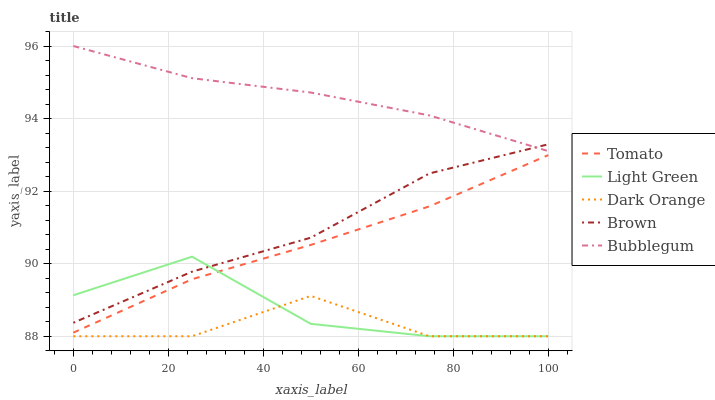Does Dark Orange have the minimum area under the curve?
Answer yes or no. Yes. Does Bubblegum have the maximum area under the curve?
Answer yes or no. Yes. Does Bubblegum have the minimum area under the curve?
Answer yes or no. No. Does Dark Orange have the maximum area under the curve?
Answer yes or no. No. Is Tomato the smoothest?
Answer yes or no. Yes. Is Light Green the roughest?
Answer yes or no. Yes. Is Dark Orange the smoothest?
Answer yes or no. No. Is Dark Orange the roughest?
Answer yes or no. No. Does Dark Orange have the lowest value?
Answer yes or no. Yes. Does Bubblegum have the lowest value?
Answer yes or no. No. Does Bubblegum have the highest value?
Answer yes or no. Yes. Does Dark Orange have the highest value?
Answer yes or no. No. Is Dark Orange less than Bubblegum?
Answer yes or no. Yes. Is Tomato greater than Dark Orange?
Answer yes or no. Yes. Does Brown intersect Bubblegum?
Answer yes or no. Yes. Is Brown less than Bubblegum?
Answer yes or no. No. Is Brown greater than Bubblegum?
Answer yes or no. No. Does Dark Orange intersect Bubblegum?
Answer yes or no. No. 